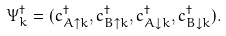Convert formula to latex. <formula><loc_0><loc_0><loc_500><loc_500>\Psi ^ { \dagger } _ { k } & = ( c ^ { \dagger } _ { A \uparrow k } , c ^ { \dagger } _ { B \uparrow k } , c ^ { \dagger } _ { A \downarrow k } , c ^ { \dagger } _ { B \downarrow k } ) .</formula> 